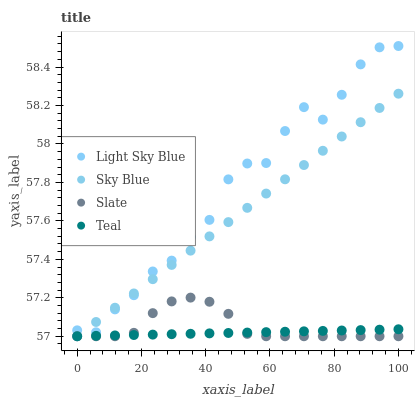Does Teal have the minimum area under the curve?
Answer yes or no. Yes. Does Light Sky Blue have the maximum area under the curve?
Answer yes or no. Yes. Does Slate have the minimum area under the curve?
Answer yes or no. No. Does Slate have the maximum area under the curve?
Answer yes or no. No. Is Teal the smoothest?
Answer yes or no. Yes. Is Light Sky Blue the roughest?
Answer yes or no. Yes. Is Slate the smoothest?
Answer yes or no. No. Is Slate the roughest?
Answer yes or no. No. Does Sky Blue have the lowest value?
Answer yes or no. Yes. Does Light Sky Blue have the lowest value?
Answer yes or no. No. Does Light Sky Blue have the highest value?
Answer yes or no. Yes. Does Slate have the highest value?
Answer yes or no. No. Is Slate less than Light Sky Blue?
Answer yes or no. Yes. Is Light Sky Blue greater than Slate?
Answer yes or no. Yes. Does Sky Blue intersect Light Sky Blue?
Answer yes or no. Yes. Is Sky Blue less than Light Sky Blue?
Answer yes or no. No. Is Sky Blue greater than Light Sky Blue?
Answer yes or no. No. Does Slate intersect Light Sky Blue?
Answer yes or no. No. 